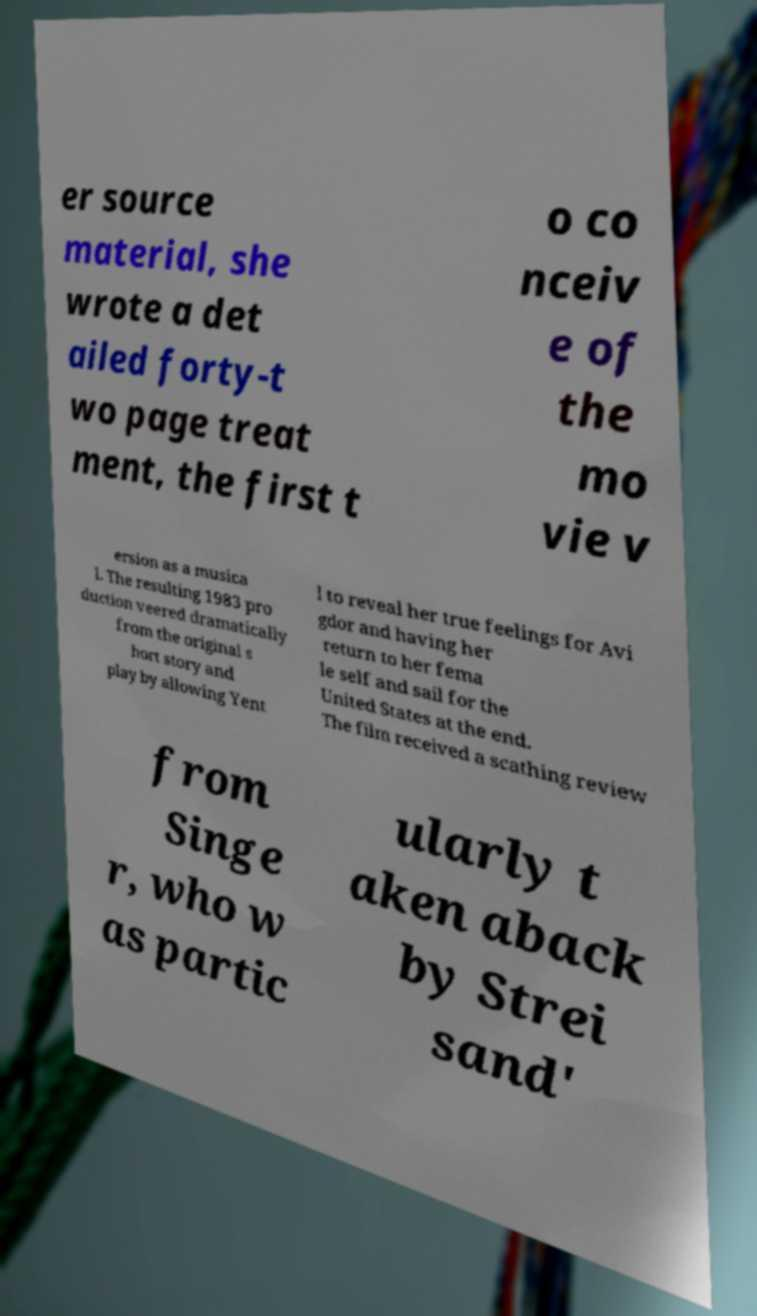There's text embedded in this image that I need extracted. Can you transcribe it verbatim? er source material, she wrote a det ailed forty-t wo page treat ment, the first t o co nceiv e of the mo vie v ersion as a musica l. The resulting 1983 pro duction veered dramatically from the original s hort story and play by allowing Yent l to reveal her true feelings for Avi gdor and having her return to her fema le self and sail for the United States at the end. The film received a scathing review from Singe r, who w as partic ularly t aken aback by Strei sand' 